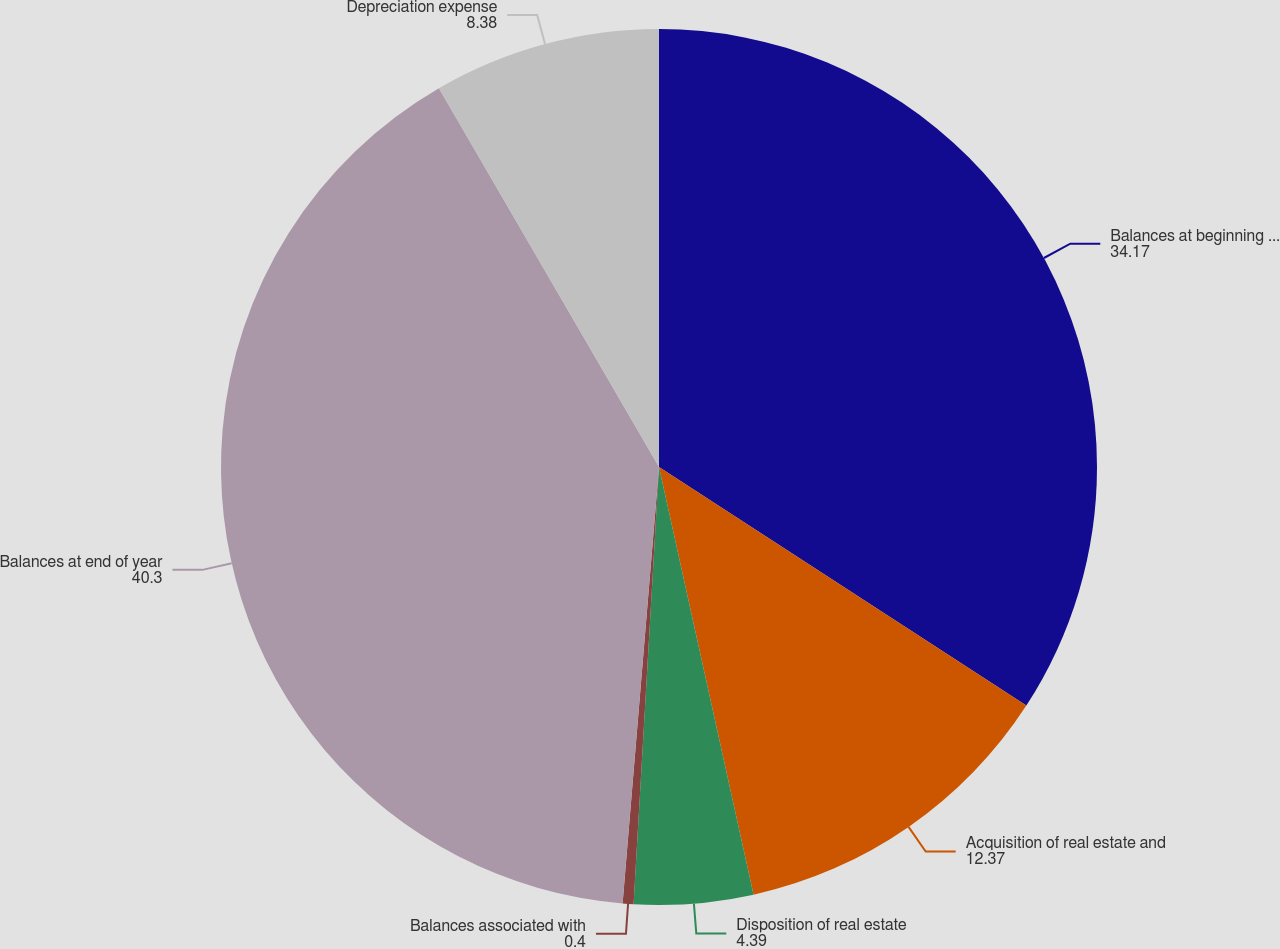Convert chart. <chart><loc_0><loc_0><loc_500><loc_500><pie_chart><fcel>Balances at beginning of year<fcel>Acquisition of real estate and<fcel>Disposition of real estate<fcel>Balances associated with<fcel>Balances at end of year<fcel>Depreciation expense<nl><fcel>34.17%<fcel>12.37%<fcel>4.39%<fcel>0.4%<fcel>40.3%<fcel>8.38%<nl></chart> 